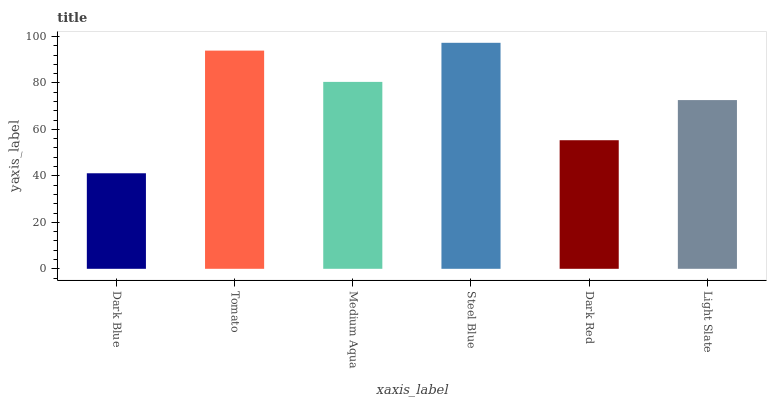Is Tomato the minimum?
Answer yes or no. No. Is Tomato the maximum?
Answer yes or no. No. Is Tomato greater than Dark Blue?
Answer yes or no. Yes. Is Dark Blue less than Tomato?
Answer yes or no. Yes. Is Dark Blue greater than Tomato?
Answer yes or no. No. Is Tomato less than Dark Blue?
Answer yes or no. No. Is Medium Aqua the high median?
Answer yes or no. Yes. Is Light Slate the low median?
Answer yes or no. Yes. Is Tomato the high median?
Answer yes or no. No. Is Steel Blue the low median?
Answer yes or no. No. 